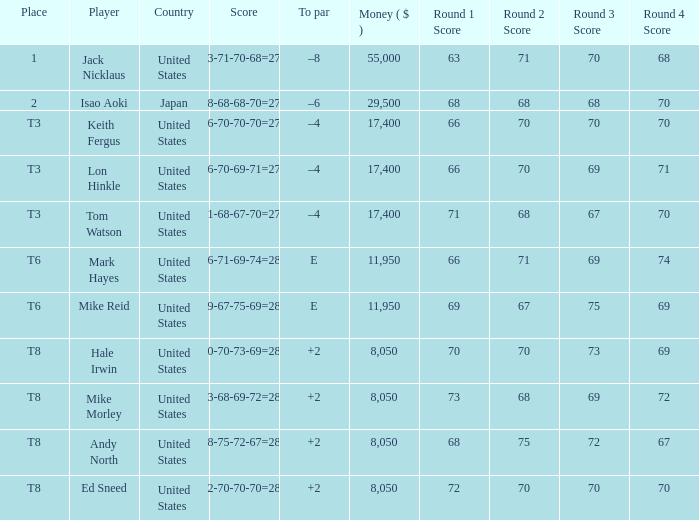What player has money larger than 11,950 and is placed in t8 and has the score of 73-68-69-72=282? None. Can you give me this table as a dict? {'header': ['Place', 'Player', 'Country', 'Score', 'To par', 'Money ( $ )', 'Round 1 Score', 'Round 2 Score', 'Round 3 Score', 'Round 4 Score'], 'rows': [['1', 'Jack Nicklaus', 'United States', '63-71-70-68=272', '–8', '55,000', '63', '71', '70', '68'], ['2', 'Isao Aoki', 'Japan', '68-68-68-70=274', '–6', '29,500', '68', '68', '68', '70'], ['T3', 'Keith Fergus', 'United States', '66-70-70-70=276', '–4', '17,400', '66', '70', '70', '70'], ['T3', 'Lon Hinkle', 'United States', '66-70-69-71=276', '–4', '17,400', '66', '70', '69', '71'], ['T3', 'Tom Watson', 'United States', '71-68-67-70=276', '–4', '17,400', '71', '68', '67', '70'], ['T6', 'Mark Hayes', 'United States', '66-71-69-74=280', 'E', '11,950', '66', '71', '69', '74'], ['T6', 'Mike Reid', 'United States', '69-67-75-69=280', 'E', '11,950', '69', '67', '75', '69'], ['T8', 'Hale Irwin', 'United States', '70-70-73-69=282', '+2', '8,050', '70', '70', '73', '69'], ['T8', 'Mike Morley', 'United States', '73-68-69-72=282', '+2', '8,050', '73', '68', '69', '72'], ['T8', 'Andy North', 'United States', '68-75-72-67=282', '+2', '8,050', '68', '75', '72', '67'], ['T8', 'Ed Sneed', 'United States', '72-70-70-70=282', '+2', '8,050', '72', '70', '70', '70']]} 